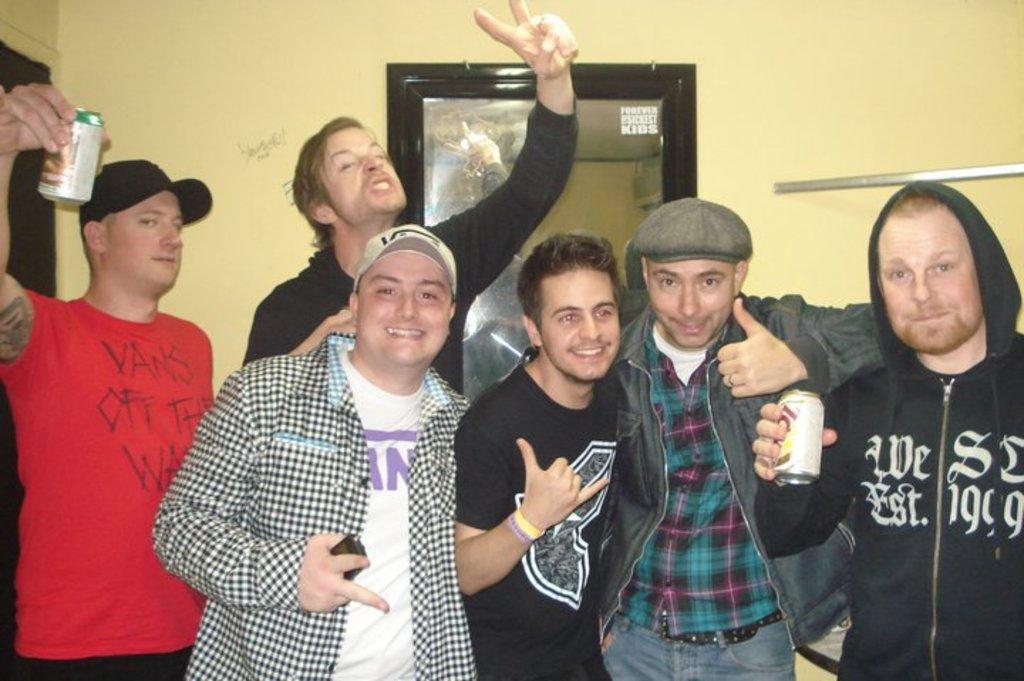What skateboard brand is on the red tshirt?
Make the answer very short. Vans. 